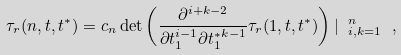<formula> <loc_0><loc_0><loc_500><loc_500>\tau _ { r } ( n , { t } , { t ^ { * } } ) = c _ { n } \det \left ( \frac { \partial ^ { i + k - 2 } } { \partial t _ { 1 } ^ { i - 1 } \partial { t _ { 1 } ^ { * } } ^ { k - 1 } } \tau _ { r } ( 1 , { t } , { t ^ { * } } ) \right ) | \ _ { i , k = 1 } ^ { n } \ ,</formula> 